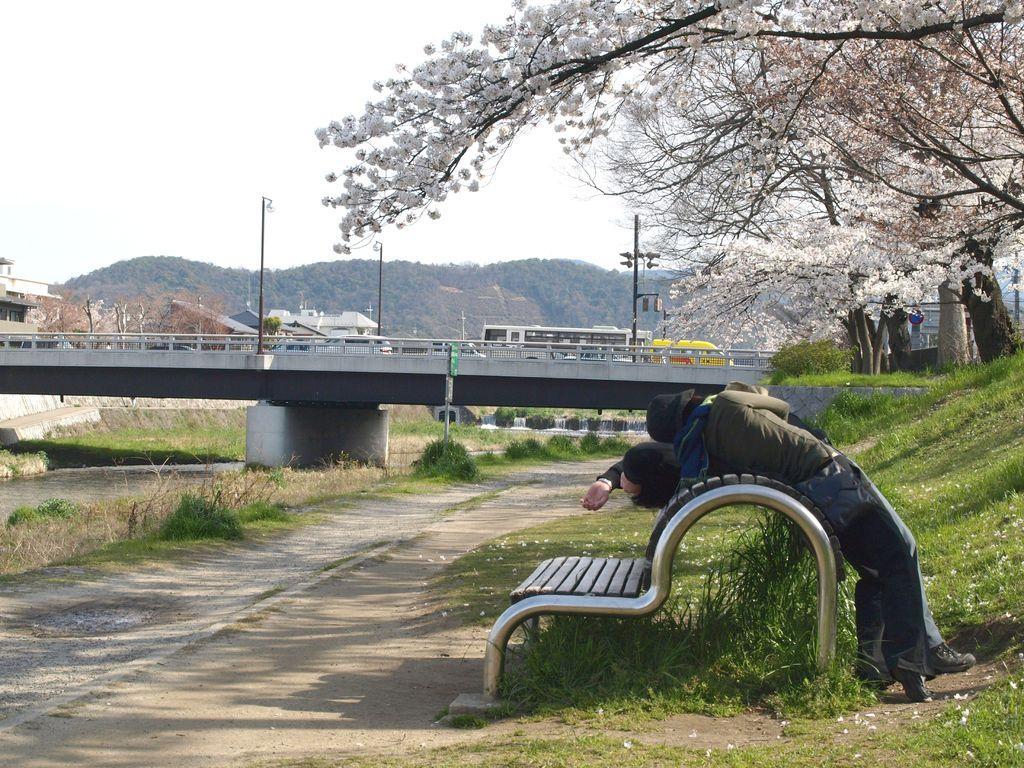Can you describe this image briefly? On the right side, there are two persons leaning on a bench, which is on the ground, on which there are flowers and grass. On the left side, there is water of a lake. Beside this lake, there is a road. Beside this road, there are plants and grass on the ground. In the background, there are trees having flowers, there are vehicles and poles on the bridge, there are buildings, trees, a mountain and there are clouds in the sky. 